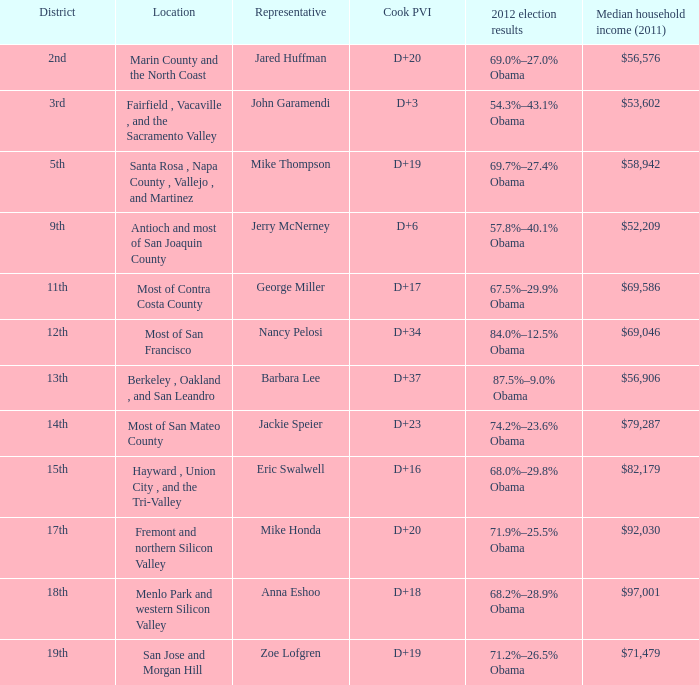What is the location that has the 12th district? Most of San Francisco. 